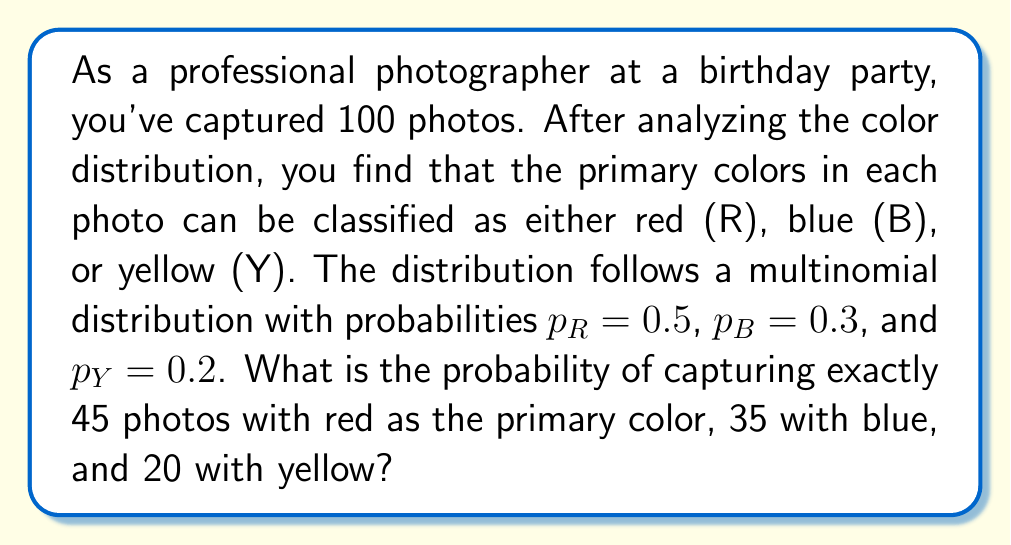Teach me how to tackle this problem. To solve this problem, we'll use the multinomial distribution formula:

$$P(X_1 = x_1, X_2 = x_2, ..., X_k = x_k) = \frac{n!}{x_1! x_2! ... x_k!} p_1^{x_1} p_2^{x_2} ... p_k^{x_k}$$

Where:
- $n$ is the total number of trials (photos)
- $x_i$ is the number of occurrences of each outcome
- $p_i$ is the probability of each outcome

Given:
- Total photos: $n = 100$
- Red photos: $x_R = 45$, $p_R = 0.5$
- Blue photos: $x_B = 35$, $p_B = 0.3$
- Yellow photos: $x_Y = 20$, $p_Y = 0.2$

Step 1: Plug the values into the formula:

$$P(X_R = 45, X_B = 35, X_Y = 20) = \frac{100!}{45! 35! 20!} (0.5)^{45} (0.3)^{35} (0.2)^{20}$$

Step 2: Calculate the factorial terms:
- $100! \approx 9.33 \times 10^{157}$
- $45! \approx 1.19 \times 10^{56}$
- $35! \approx 1.03 \times 10^{40}$
- $20! \approx 2.43 \times 10^{18}$

Step 3: Calculate the power terms:
- $(0.5)^{45} \approx 2.84 \times 10^{-14}$
- $(0.3)^{35} \approx 1.43 \times 10^{-18}$
- $(0.2)^{20} \approx 1.05 \times 10^{-14}$

Step 4: Combine all terms and calculate the final probability:

$$\frac{9.33 \times 10^{157}}{(1.19 \times 10^{56})(1.03 \times 10^{40})(2.43 \times 10^{18})} \times (2.84 \times 10^{-14})(1.43 \times 10^{-18})(1.05 \times 10^{-14}) \approx 0.0389$$
Answer: The probability of capturing exactly 45 photos with red as the primary color, 35 with blue, and 20 with yellow is approximately 0.0389 or 3.89%. 